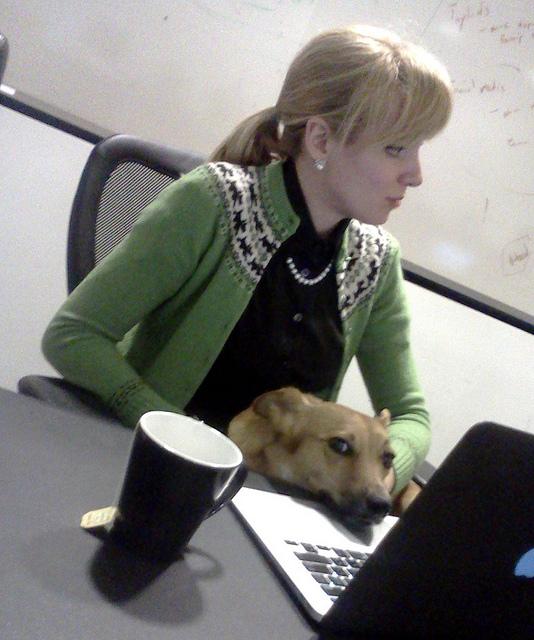What kind of drink is likely in the mug?
Short answer required. Coffee. Does this look like a home setting?
Concise answer only. No. What is the dog looking at?
Give a very brief answer. Camera. 